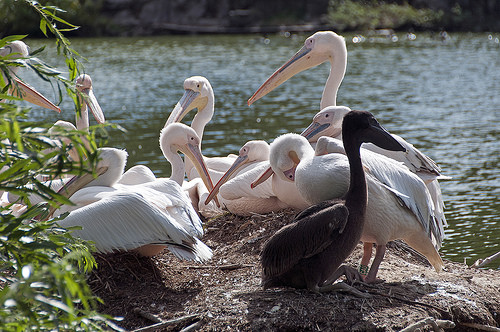<image>
Is the white bird behind the black bird? Yes. From this viewpoint, the white bird is positioned behind the black bird, with the black bird partially or fully occluding the white bird. 